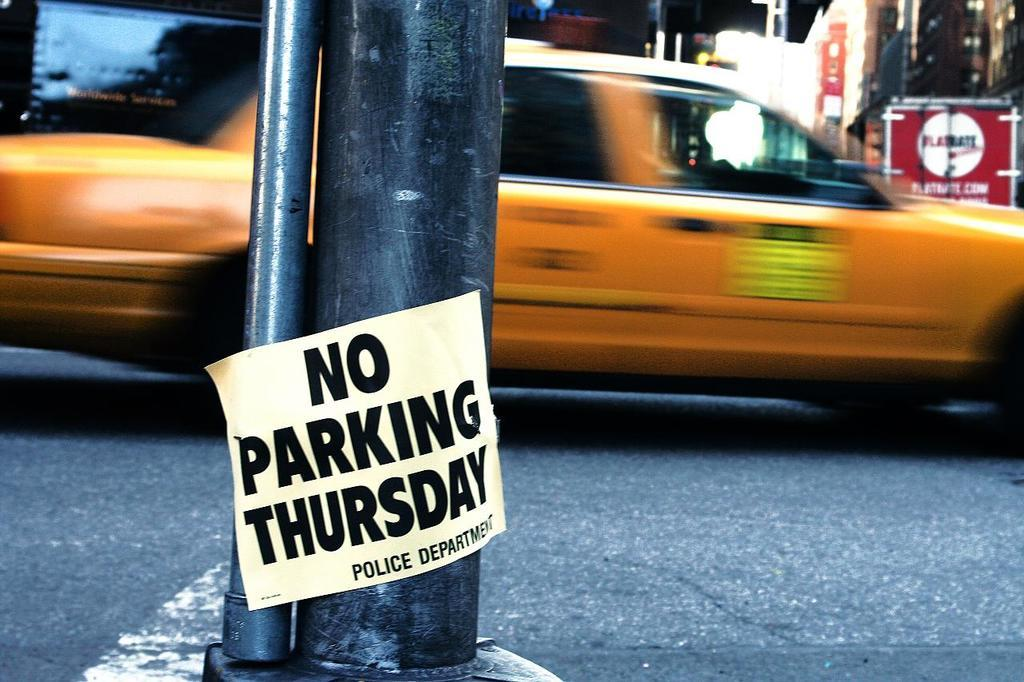<image>
Offer a succinct explanation of the picture presented. Taxi car riding by with no parking Thursday sign on a pole 